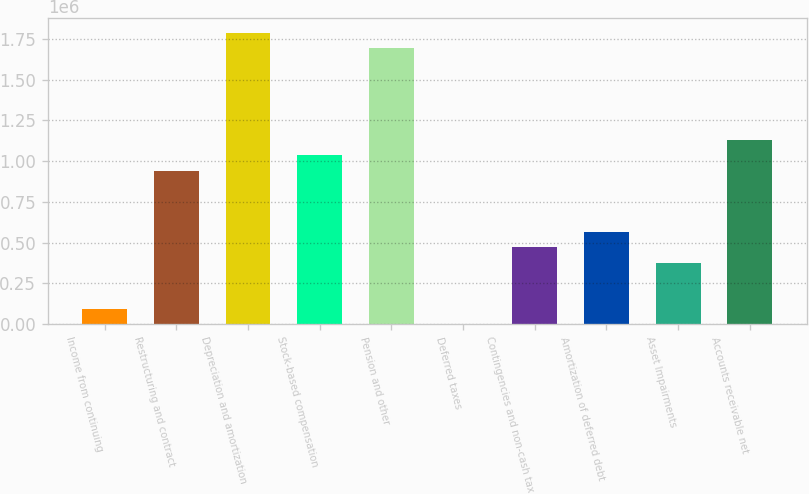Convert chart. <chart><loc_0><loc_0><loc_500><loc_500><bar_chart><fcel>Income from continuing<fcel>Restructuring and contract<fcel>Depreciation and amortization<fcel>Stock-based compensation<fcel>Pension and other<fcel>Deferred taxes<fcel>Contingencies and non-cash tax<fcel>Amortization of deferred debt<fcel>Asset Impairments<fcel>Accounts receivable net<nl><fcel>94471.4<fcel>942113<fcel>1.78975e+06<fcel>1.0363e+06<fcel>1.69557e+06<fcel>289<fcel>471201<fcel>565383<fcel>377019<fcel>1.13048e+06<nl></chart> 